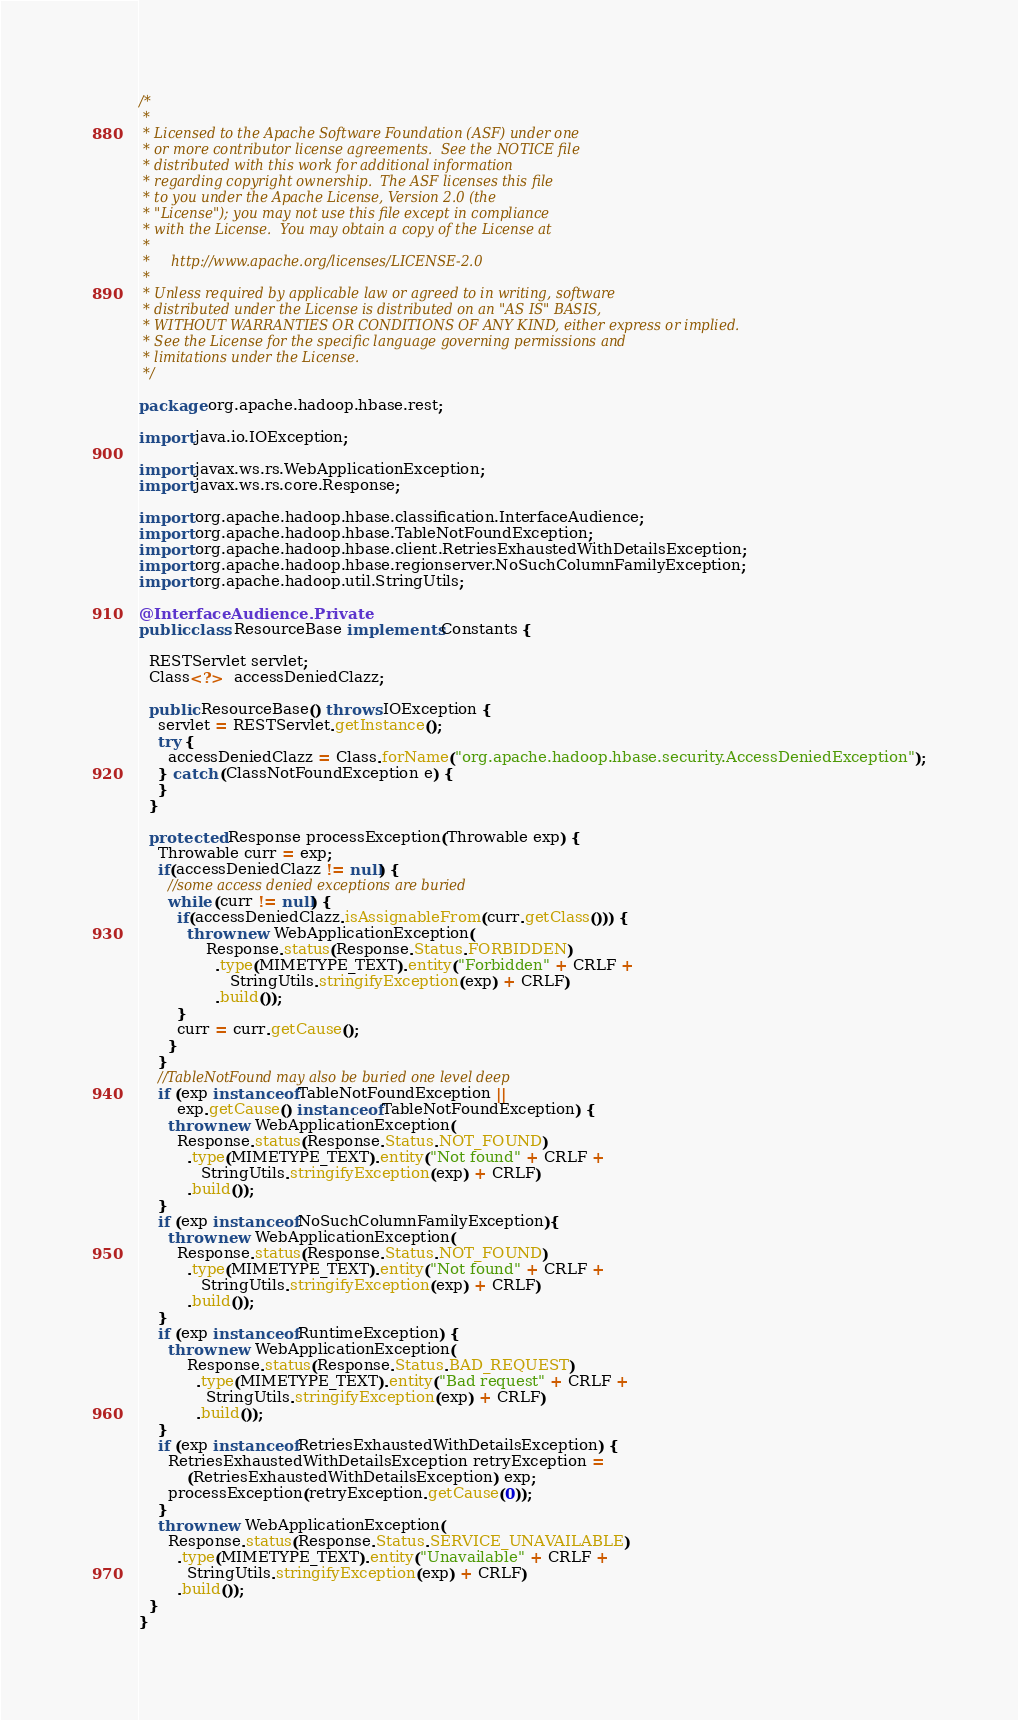Convert code to text. <code><loc_0><loc_0><loc_500><loc_500><_Java_>/*
 *
 * Licensed to the Apache Software Foundation (ASF) under one
 * or more contributor license agreements.  See the NOTICE file
 * distributed with this work for additional information
 * regarding copyright ownership.  The ASF licenses this file
 * to you under the Apache License, Version 2.0 (the
 * "License"); you may not use this file except in compliance
 * with the License.  You may obtain a copy of the License at
 *
 *     http://www.apache.org/licenses/LICENSE-2.0
 *
 * Unless required by applicable law or agreed to in writing, software
 * distributed under the License is distributed on an "AS IS" BASIS,
 * WITHOUT WARRANTIES OR CONDITIONS OF ANY KIND, either express or implied.
 * See the License for the specific language governing permissions and
 * limitations under the License.
 */

package org.apache.hadoop.hbase.rest;

import java.io.IOException;

import javax.ws.rs.WebApplicationException;
import javax.ws.rs.core.Response;

import org.apache.hadoop.hbase.classification.InterfaceAudience;
import org.apache.hadoop.hbase.TableNotFoundException;
import org.apache.hadoop.hbase.client.RetriesExhaustedWithDetailsException;
import org.apache.hadoop.hbase.regionserver.NoSuchColumnFamilyException;
import org.apache.hadoop.util.StringUtils;

@InterfaceAudience.Private
public class ResourceBase implements Constants {

  RESTServlet servlet;
  Class<?>  accessDeniedClazz;

  public ResourceBase() throws IOException {
    servlet = RESTServlet.getInstance();
    try {
      accessDeniedClazz = Class.forName("org.apache.hadoop.hbase.security.AccessDeniedException");
    } catch (ClassNotFoundException e) {
    }
  }
  
  protected Response processException(Throwable exp) {
    Throwable curr = exp;
    if(accessDeniedClazz != null) {
      //some access denied exceptions are buried
      while (curr != null) {
        if(accessDeniedClazz.isAssignableFrom(curr.getClass())) {
          throw new WebApplicationException(
              Response.status(Response.Status.FORBIDDEN)
                .type(MIMETYPE_TEXT).entity("Forbidden" + CRLF +
                   StringUtils.stringifyException(exp) + CRLF)
                .build());
        }
        curr = curr.getCause();
      }
    }
    //TableNotFound may also be buried one level deep
    if (exp instanceof TableNotFoundException ||
        exp.getCause() instanceof TableNotFoundException) {
      throw new WebApplicationException(
        Response.status(Response.Status.NOT_FOUND)
          .type(MIMETYPE_TEXT).entity("Not found" + CRLF +
             StringUtils.stringifyException(exp) + CRLF)
          .build());
    }
    if (exp instanceof NoSuchColumnFamilyException){
      throw new WebApplicationException(
        Response.status(Response.Status.NOT_FOUND)
          .type(MIMETYPE_TEXT).entity("Not found" + CRLF +
             StringUtils.stringifyException(exp) + CRLF)
          .build());
    }
    if (exp instanceof RuntimeException) {
      throw new WebApplicationException(
          Response.status(Response.Status.BAD_REQUEST)
            .type(MIMETYPE_TEXT).entity("Bad request" + CRLF +
              StringUtils.stringifyException(exp) + CRLF)
            .build());
    }
    if (exp instanceof RetriesExhaustedWithDetailsException) {
      RetriesExhaustedWithDetailsException retryException =
          (RetriesExhaustedWithDetailsException) exp;
      processException(retryException.getCause(0));
    }
    throw new WebApplicationException(
      Response.status(Response.Status.SERVICE_UNAVAILABLE)
        .type(MIMETYPE_TEXT).entity("Unavailable" + CRLF +
          StringUtils.stringifyException(exp) + CRLF)
        .build());
  }
}
</code> 